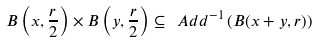Convert formula to latex. <formula><loc_0><loc_0><loc_500><loc_500>B \left ( x , \frac { r } { 2 } \right ) \times B \left ( y , \frac { r } { 2 } \right ) \subseteq \ A d d ^ { - 1 } \left ( B ( x + y , r ) \right )</formula> 